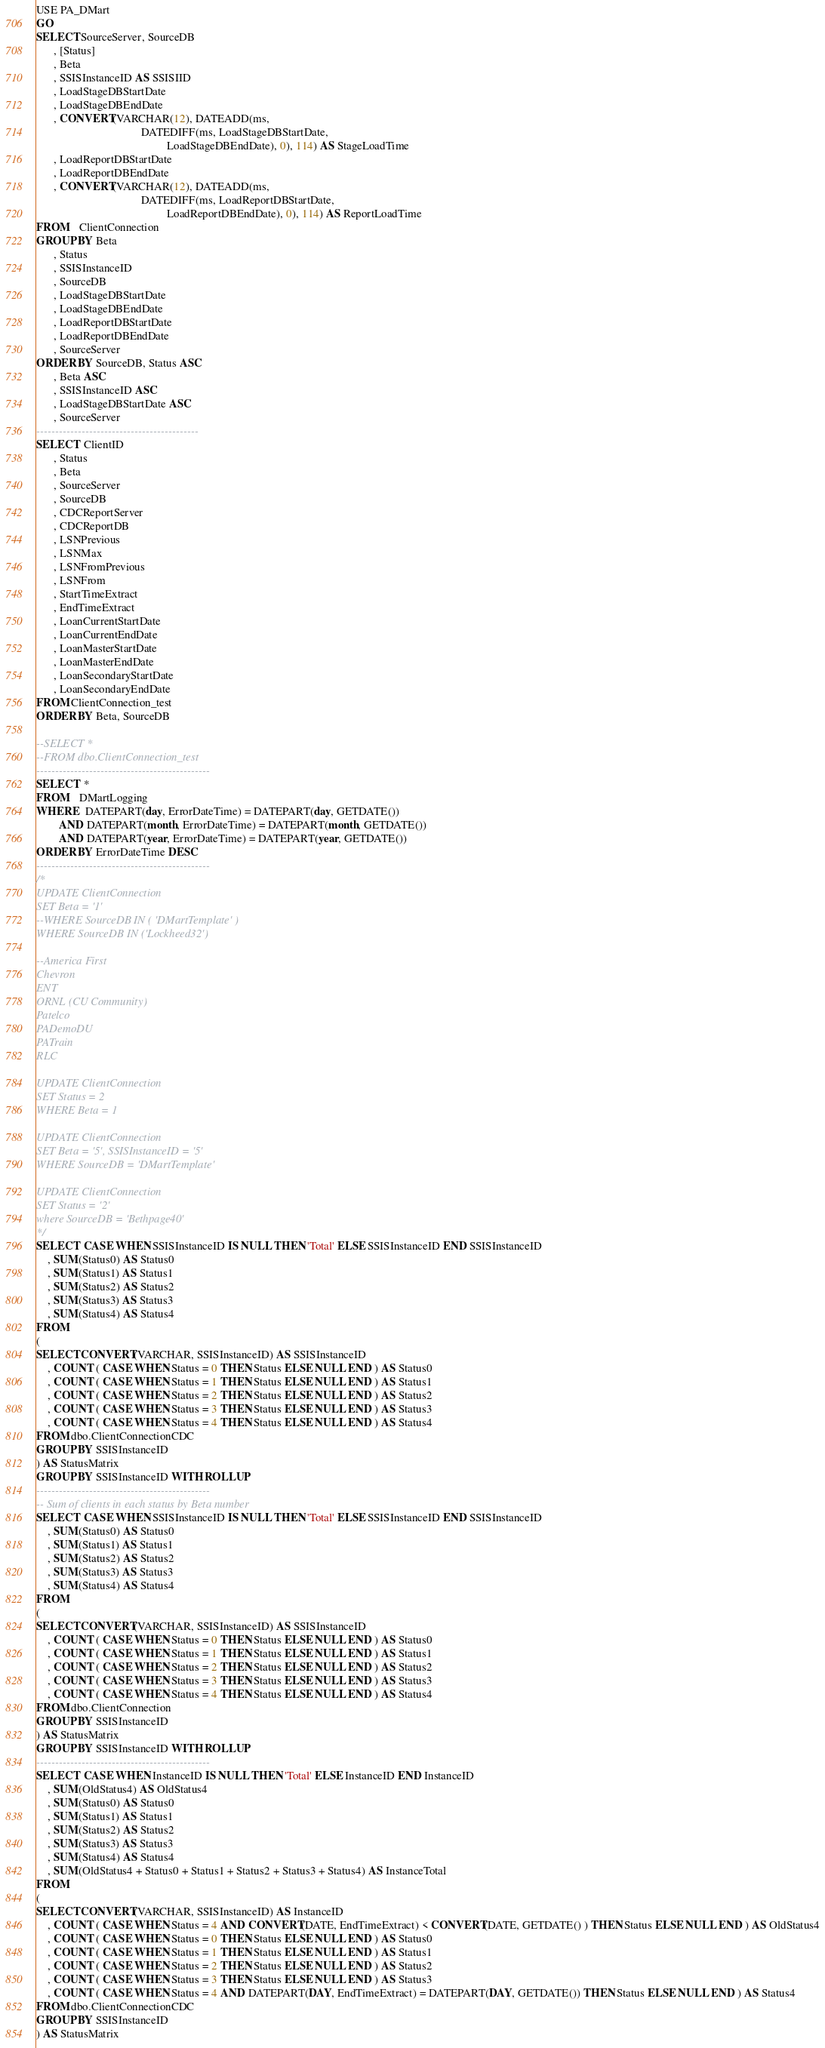Convert code to text. <code><loc_0><loc_0><loc_500><loc_500><_SQL_>USE PA_DMart
GO
SELECT SourceServer, SourceDB
      , [Status]
      , Beta
      , SSISInstanceID AS SSISIID
      , LoadStageDBStartDate
      , LoadStageDBEndDate
      , CONVERT(VARCHAR(12), DATEADD(ms,
                                     DATEDIFF(ms, LoadStageDBStartDate,
                                              LoadStageDBEndDate), 0), 114) AS StageLoadTime
      , LoadReportDBStartDate
      , LoadReportDBEndDate
      , CONVERT(VARCHAR(12), DATEADD(ms,
                                     DATEDIFF(ms, LoadReportDBStartDate,
                                              LoadReportDBEndDate), 0), 114) AS ReportLoadTime
FROM    ClientConnection
GROUP BY Beta
      , Status
      , SSISInstanceID
      , SourceDB
      , LoadStageDBStartDate
      , LoadStageDBEndDate
      , LoadReportDBStartDate
      , LoadReportDBEndDate
      , SourceServer
ORDER BY SourceDB, Status ASC
      , Beta ASC
      , SSISInstanceID ASC
      , LoadStageDBStartDate ASC
      , SourceServer
-------------------------------------------
SELECT  ClientID
      , Status
      , Beta
      , SourceServer
      , SourceDB
      , CDCReportServer
      , CDCReportDB
      , LSNPrevious
      , LSNMax
      , LSNFromPrevious
      , LSNFrom
      , StartTimeExtract
      , EndTimeExtract
      , LoanCurrentStartDate
      , LoanCurrentEndDate
      , LoanMasterStartDate
      , LoanMasterEndDate
      , LoanSecondaryStartDate
      , LoanSecondaryEndDate
FROM ClientConnection_test
ORDER BY Beta, SourceDB

--SELECT *
--FROM dbo.ClientConnection_test
----------------------------------------------
SELECT  *
FROM    DMartLogging
WHERE   DATEPART(day, ErrorDateTime) = DATEPART(day, GETDATE())
        AND DATEPART(month, ErrorDateTime) = DATEPART(month, GETDATE())
        AND DATEPART(year, ErrorDateTime) = DATEPART(year, GETDATE())
ORDER BY ErrorDateTime DESC
----------------------------------------------
/*
UPDATE ClientConnection
SET Beta = '1'
--WHERE SourceDB IN ( 'DMartTemplate' )
WHERE SourceDB IN ('Lockheed32')

--America First
Chevron
ENT
ORNL (CU Community)
Patelco
PADemoDU
PATrain
RLC

UPDATE ClientConnection
SET Status = 2
WHERE Beta = 1

UPDATE ClientConnection
SET Beta = '5', SSISInstanceID = '5'
WHERE SourceDB = 'DMartTemplate'

UPDATE ClientConnection
SET Status = '2'
where SourceDB = 'Bethpage40'
*/
SELECT  CASE WHEN SSISInstanceID IS NULL THEN 'Total' ELSE SSISInstanceID END SSISInstanceID
	, SUM(Status0) AS Status0
	, SUM(Status1) AS Status1
	, SUM(Status2) AS Status2
	, SUM(Status3) AS Status3
	, SUM(Status4) AS Status4
FROM
(
SELECT CONVERT(VARCHAR, SSISInstanceID) AS SSISInstanceID 
	, COUNT ( CASE WHEN Status = 0 THEN Status ELSE NULL END ) AS Status0
	, COUNT ( CASE WHEN Status = 1 THEN Status ELSE NULL END ) AS Status1
	, COUNT ( CASE WHEN Status = 2 THEN Status ELSE NULL END ) AS Status2
	, COUNT ( CASE WHEN Status = 3 THEN Status ELSE NULL END ) AS Status3
	, COUNT ( CASE WHEN Status = 4 THEN Status ELSE NULL END ) AS Status4
FROM dbo.ClientConnectionCDC
GROUP BY SSISInstanceID
) AS StatusMatrix
GROUP BY SSISInstanceID WITH ROLLUP
----------------------------------------------
-- Sum of clients in each status by Beta number
SELECT  CASE WHEN SSISInstanceID IS NULL THEN 'Total' ELSE SSISInstanceID END SSISInstanceID
	, SUM(Status0) AS Status0
	, SUM(Status1) AS Status1
	, SUM(Status2) AS Status2
	, SUM(Status3) AS Status3
	, SUM(Status4) AS Status4
FROM
(
SELECT CONVERT(VARCHAR, SSISInstanceID) AS SSISInstanceID 
	, COUNT ( CASE WHEN Status = 0 THEN Status ELSE NULL END ) AS Status0
	, COUNT ( CASE WHEN Status = 1 THEN Status ELSE NULL END ) AS Status1
	, COUNT ( CASE WHEN Status = 2 THEN Status ELSE NULL END ) AS Status2
	, COUNT ( CASE WHEN Status = 3 THEN Status ELSE NULL END ) AS Status3
	, COUNT ( CASE WHEN Status = 4 THEN Status ELSE NULL END ) AS Status4
FROM dbo.ClientConnection
GROUP BY SSISInstanceID
) AS StatusMatrix
GROUP BY SSISInstanceID WITH ROLLUP
----------------------------------------------
SELECT  CASE WHEN InstanceID IS NULL THEN 'Total' ELSE InstanceID END InstanceID
	, SUM(OldStatus4) AS OldStatus4
	, SUM(Status0) AS Status0
	, SUM(Status1) AS Status1
	, SUM(Status2) AS Status2
	, SUM(Status3) AS Status3
	, SUM(Status4) AS Status4
	, SUM(OldStatus4 + Status0 + Status1 + Status2 + Status3 + Status4) AS InstanceTotal
FROM
(
SELECT CONVERT(VARCHAR, SSISInstanceID) AS InstanceID
	, COUNT ( CASE WHEN Status = 4 AND CONVERT(DATE, EndTimeExtract) < CONVERT(DATE, GETDATE() ) THEN Status ELSE NULL END ) AS OldStatus4
	, COUNT ( CASE WHEN Status = 0 THEN Status ELSE NULL END ) AS Status0
	, COUNT ( CASE WHEN Status = 1 THEN Status ELSE NULL END ) AS Status1
	, COUNT ( CASE WHEN Status = 2 THEN Status ELSE NULL END ) AS Status2
	, COUNT ( CASE WHEN Status = 3 THEN Status ELSE NULL END ) AS Status3
	, COUNT ( CASE WHEN Status = 4 AND DATEPART(DAY, EndTimeExtract) = DATEPART(DAY, GETDATE()) THEN Status ELSE NULL END ) AS Status4
FROM dbo.ClientConnectionCDC
GROUP BY SSISInstanceID
) AS StatusMatrix</code> 